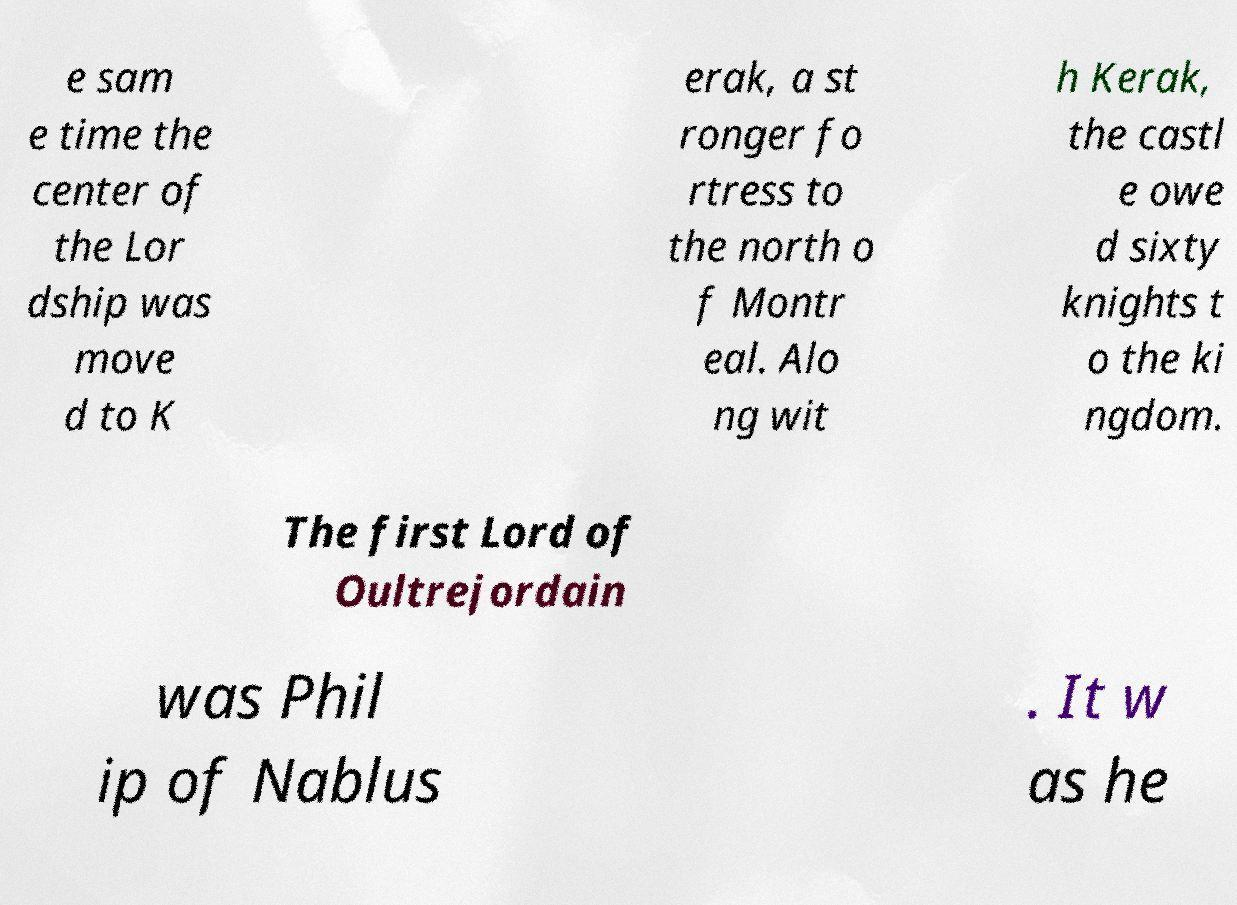I need the written content from this picture converted into text. Can you do that? e sam e time the center of the Lor dship was move d to K erak, a st ronger fo rtress to the north o f Montr eal. Alo ng wit h Kerak, the castl e owe d sixty knights t o the ki ngdom. The first Lord of Oultrejordain was Phil ip of Nablus . It w as he 